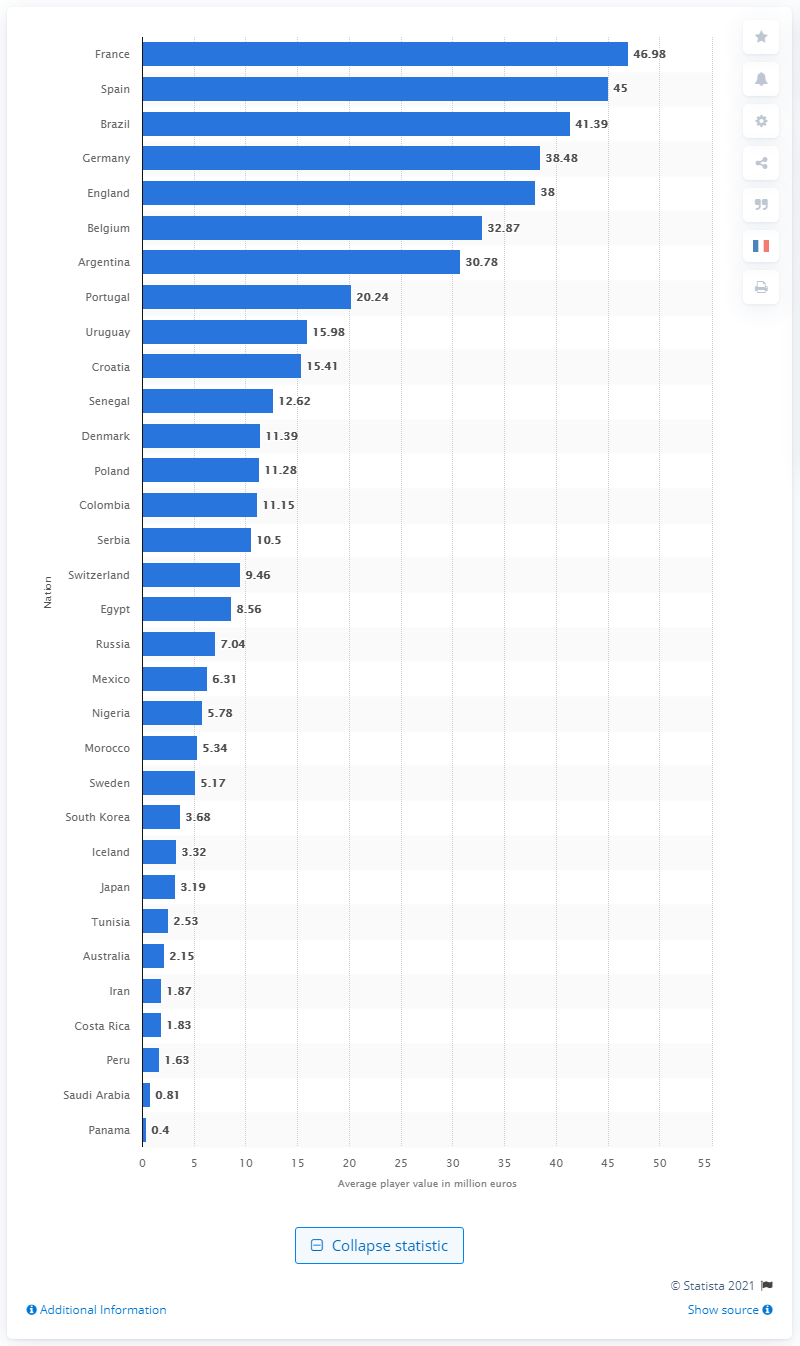Specify some key components in this picture. The 2018 FIFA World Cup was held in Russia. The average market value of the players on the French national team at the 2018 FIFA World Cup was 46.98. 